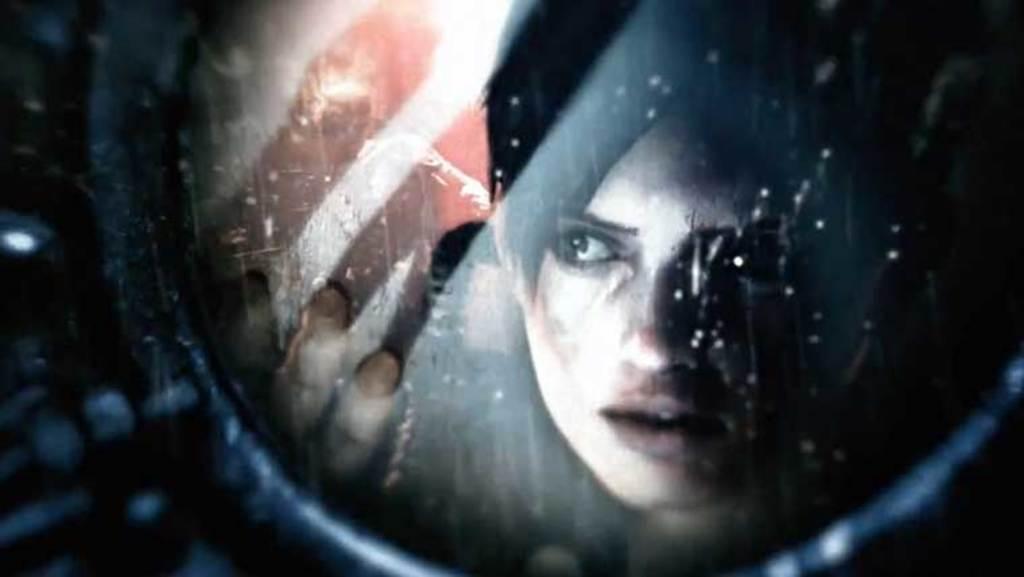Please provide a concise description of this image. In this picture there is a girl on the right side of the image. 